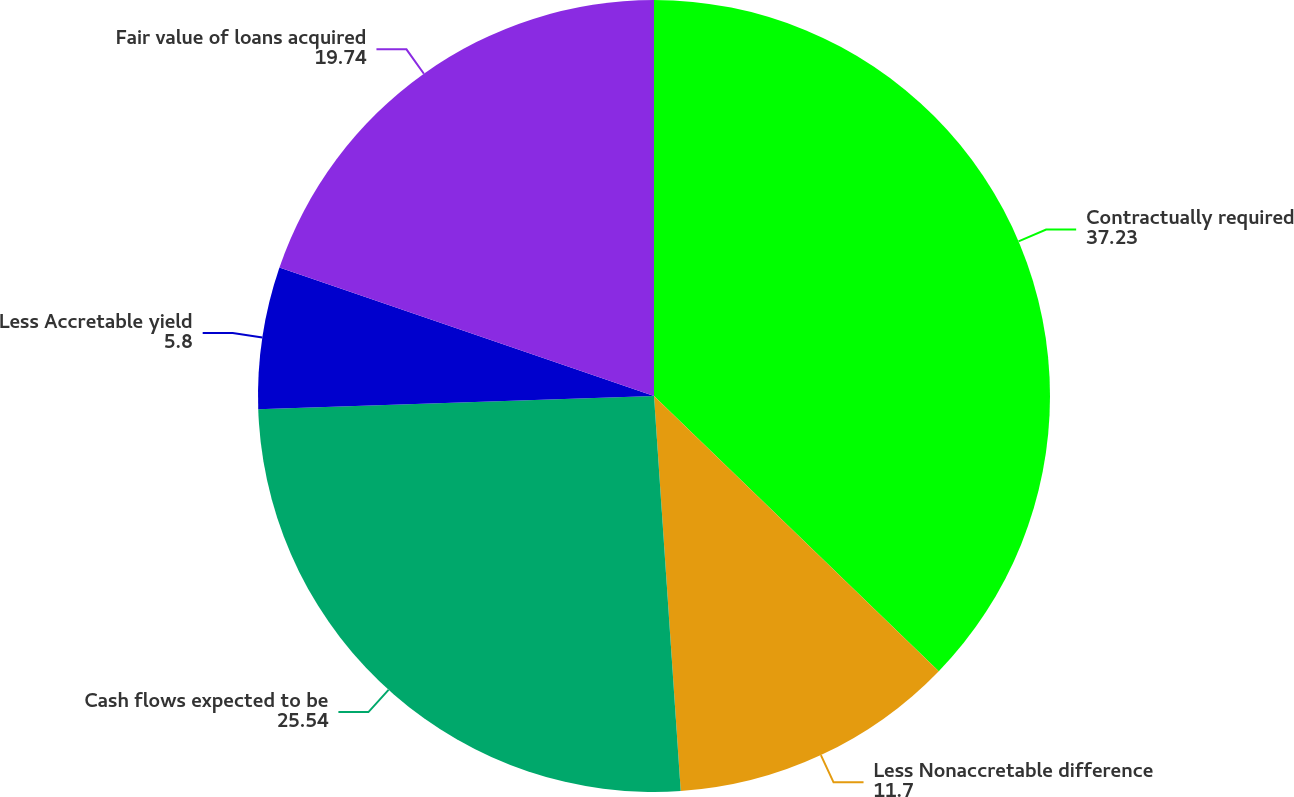Convert chart. <chart><loc_0><loc_0><loc_500><loc_500><pie_chart><fcel>Contractually required<fcel>Less Nonaccretable difference<fcel>Cash flows expected to be<fcel>Less Accretable yield<fcel>Fair value of loans acquired<nl><fcel>37.23%<fcel>11.7%<fcel>25.54%<fcel>5.8%<fcel>19.74%<nl></chart> 